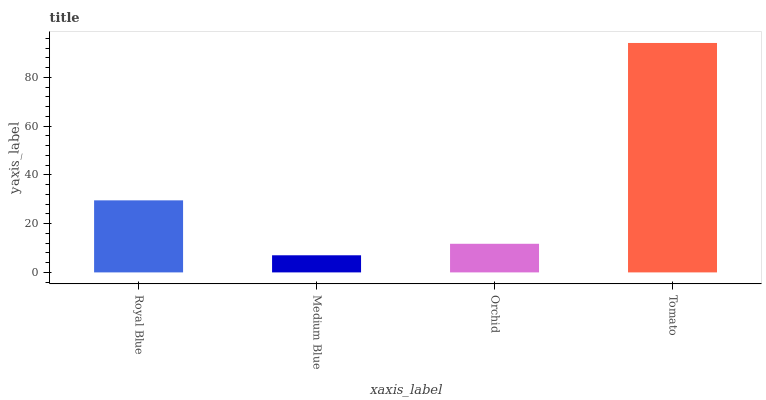Is Medium Blue the minimum?
Answer yes or no. Yes. Is Tomato the maximum?
Answer yes or no. Yes. Is Orchid the minimum?
Answer yes or no. No. Is Orchid the maximum?
Answer yes or no. No. Is Orchid greater than Medium Blue?
Answer yes or no. Yes. Is Medium Blue less than Orchid?
Answer yes or no. Yes. Is Medium Blue greater than Orchid?
Answer yes or no. No. Is Orchid less than Medium Blue?
Answer yes or no. No. Is Royal Blue the high median?
Answer yes or no. Yes. Is Orchid the low median?
Answer yes or no. Yes. Is Orchid the high median?
Answer yes or no. No. Is Royal Blue the low median?
Answer yes or no. No. 